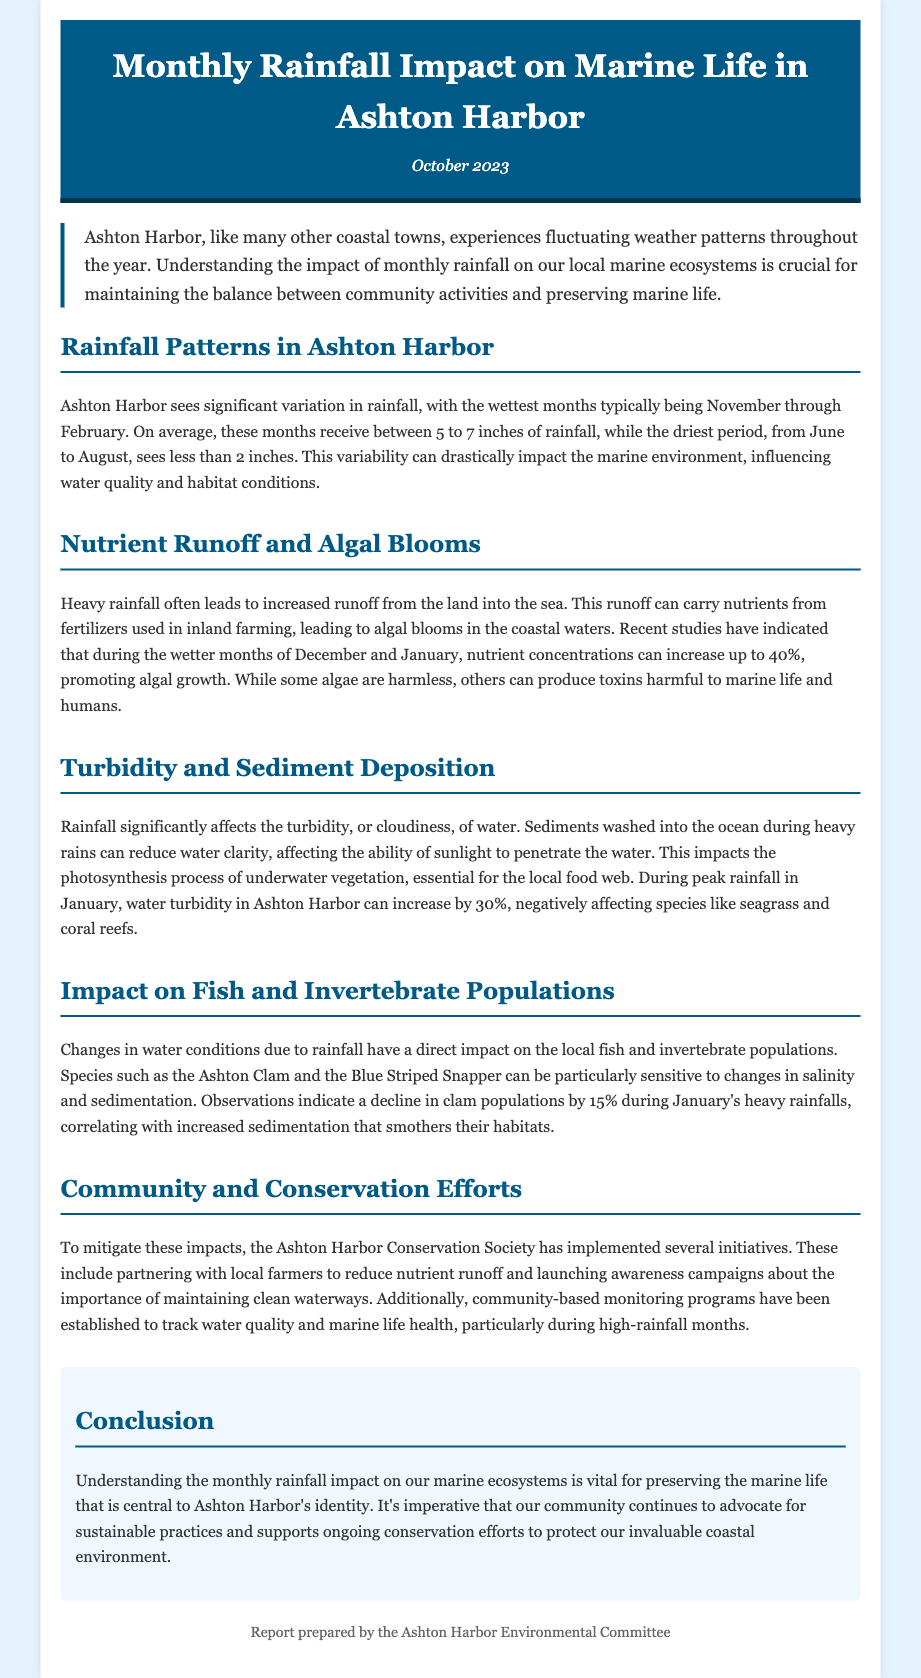What are the wettest months in Ashton Harbor? The wettest months typically are November through February.
Answer: November through February What average rainfall is received in the wettest months? The average rainfall in the wettest months is between 5 to 7 inches.
Answer: 5 to 7 inches What nutrient concentration increase can occur during December and January? Nutrient concentrations can increase up to 40% during these months.
Answer: 40% What species shows a decline during January's heavy rainfalls? The Ashton Clam shows a decline during heavy rainfalls.
Answer: Ashton Clam What impact can turbidity have on underwater vegetation? Turbidity can reduce water clarity, affecting photosynthesis in underwater vegetation.
Answer: Reduce water clarity What organization has launched initiatives to mitigate rainfall impacts? The Ashton Harbor Conservation Society has implemented initiatives.
Answer: Ashton Harbor Conservation Society What is the main focus of the community-based monitoring programs? The focus is to track water quality and marine life health.
Answer: Track water quality How much can water turbidity increase during peak rainfall in January? Water turbidity can increase by 30% during this period.
Answer: 30% 